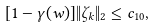Convert formula to latex. <formula><loc_0><loc_0><loc_500><loc_500>[ 1 - \gamma ( w ) ] \| \zeta _ { k } \| _ { 2 } \leq c _ { 1 0 } ,</formula> 